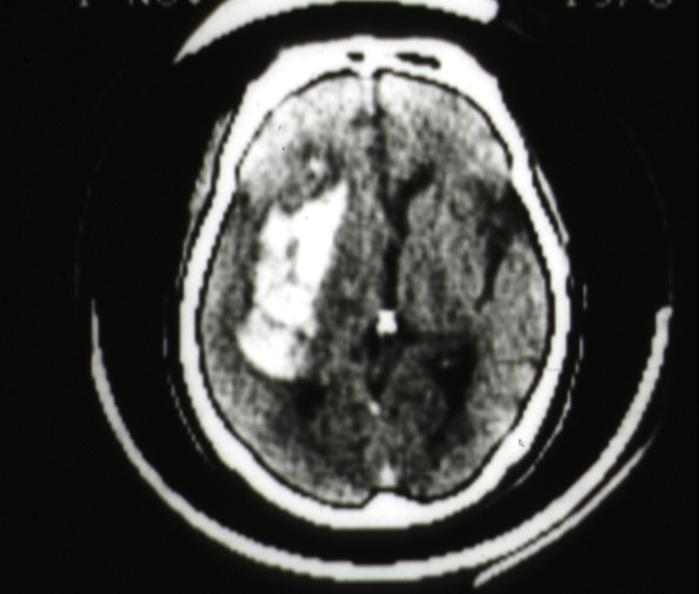does this image show cat scan hemorrhage in putamen area?
Answer the question using a single word or phrase. Yes 